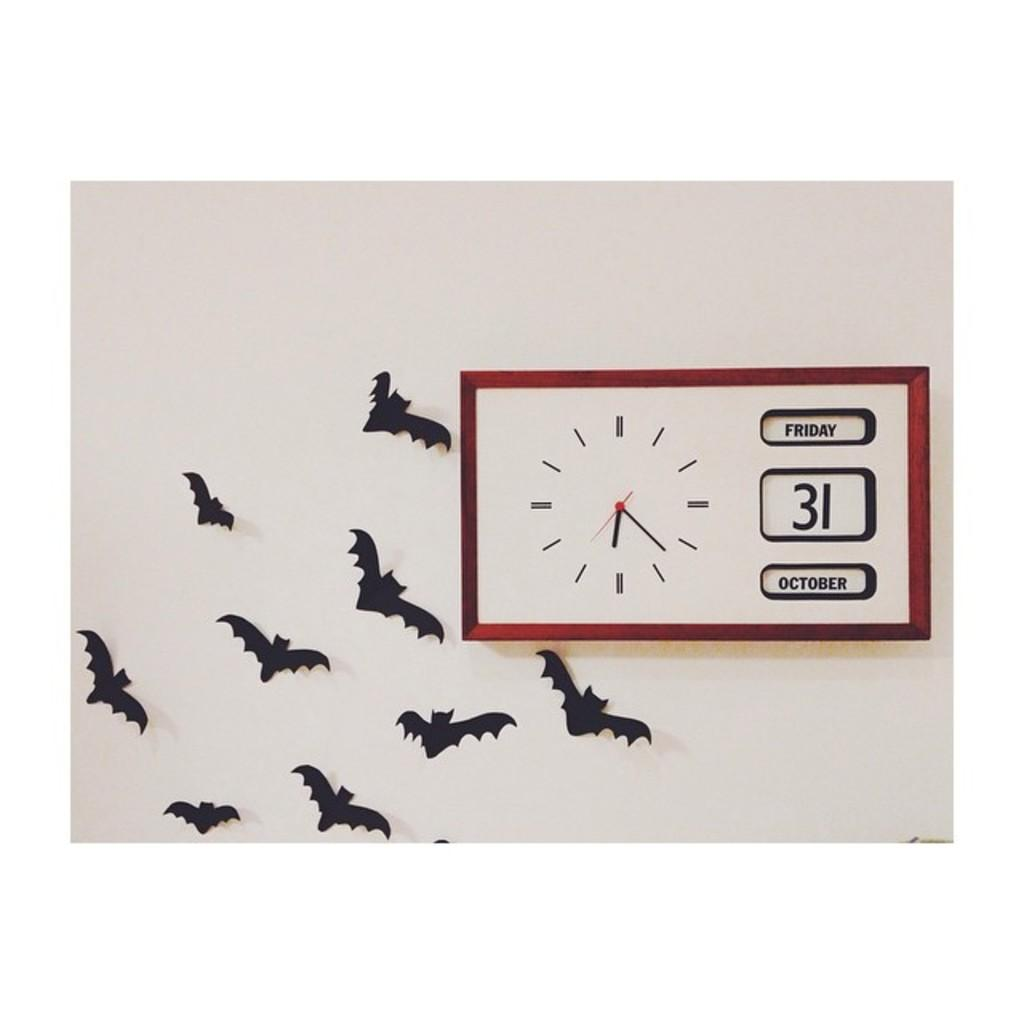Provide a one-sentence caption for the provided image. Plastic bats are on the wall beside a clock with the date of Friday October 31st on it. 